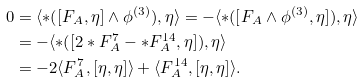<formula> <loc_0><loc_0><loc_500><loc_500>0 & = \langle \ast ( [ F _ { A } , \eta ] \wedge \phi ^ { ( 3 ) } ) , \eta \rangle = - \langle \ast ( [ F _ { A } \wedge \phi ^ { ( 3 ) } , \eta ] ) , \eta \rangle \\ & = - \langle \ast ( [ 2 \ast F ^ { 7 } _ { A } - \ast F ^ { 1 4 } _ { A } , \eta ] ) , \eta \rangle \\ & = - 2 \langle F ^ { 7 } _ { A } , [ \eta , \eta ] \rangle + \langle F ^ { 1 4 } _ { A } , [ \eta , \eta ] \rangle . \\</formula> 